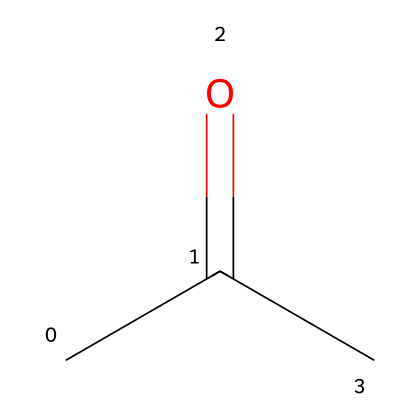How many carbon atoms are in acetone? The SMILES representation "CC(=O)C" indicates that there are three carbon atoms in the structure. Each 'C' in the SMILES corresponds to a carbon atom.
Answer: three What type of functional group is present in acetone? The part of the SMILES "C(=O)" shows a carbon double-bonded to an oxygen atom, which identifies it as a ketone functional group.
Answer: ketone How many hydrogen atoms are in acetone? Following the structure given by the SMILES "CC(=O)C", the total number of hydrogen atoms can be calculated as 6 (2 from each of the two terminal carbons, and 1 from the central carbon with the oxygen).
Answer: six What is the molecular formula of acetone? The compound is made up of three carbon (C) atoms, six hydrogen (H) atoms, and one oxygen (O) atom, leading to the molecular formula C3H6O based on its structure.
Answer: C3H6O Why is acetone considered a good solvent in art supplies? Acetone has a low molecular weight and a polar structure allowing it to dissolve both polar and non-polar substances effectively, making it highly suitable for various materials used in art.
Answer: good solvent How does the presence of the π-bond in acetone affect its reactivity? The π-bond between the carbon and oxygen (C=O) creates a polar bond, making it an electrophilic site which can react with nucleophiles, enhancing its reactivity compared to alkanes.
Answer: increases reactivity 